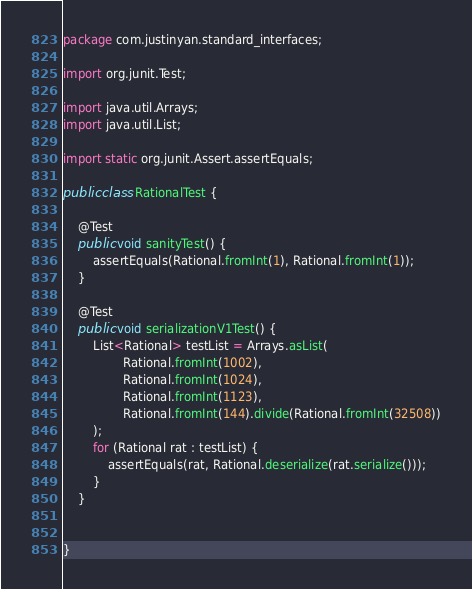<code> <loc_0><loc_0><loc_500><loc_500><_Java_>package com.justinyan.standard_interfaces;

import org.junit.Test;

import java.util.Arrays;
import java.util.List;

import static org.junit.Assert.assertEquals;

public class RationalTest {

    @Test
    public void sanityTest() {
        assertEquals(Rational.fromInt(1), Rational.fromInt(1));
    }

    @Test
    public void serializationV1Test() {
        List<Rational> testList = Arrays.asList(
                Rational.fromInt(1002),
                Rational.fromInt(1024),
                Rational.fromInt(1123),
                Rational.fromInt(144).divide(Rational.fromInt(32508))
        );
        for (Rational rat : testList) {
            assertEquals(rat, Rational.deserialize(rat.serialize()));
        }
    }


}
</code> 